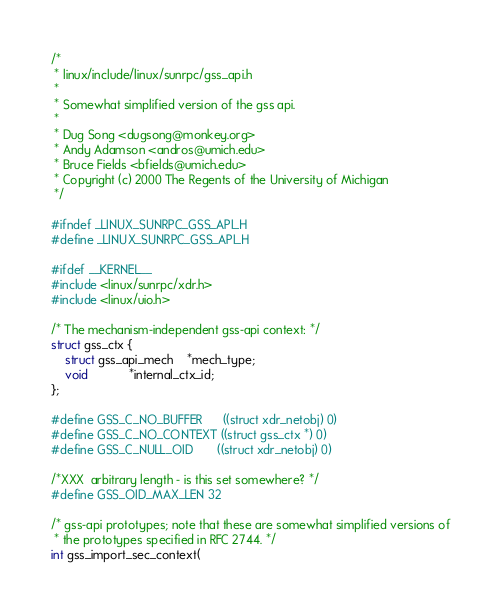Convert code to text. <code><loc_0><loc_0><loc_500><loc_500><_C_>/*
 * linux/include/linux/sunrpc/gss_api.h
 *
 * Somewhat simplified version of the gss api.
 *
 * Dug Song <dugsong@monkey.org>
 * Andy Adamson <andros@umich.edu>
 * Bruce Fields <bfields@umich.edu>
 * Copyright (c) 2000 The Regents of the University of Michigan
 */

#ifndef _LINUX_SUNRPC_GSS_API_H
#define _LINUX_SUNRPC_GSS_API_H

#ifdef __KERNEL__
#include <linux/sunrpc/xdr.h>
#include <linux/uio.h>

/* The mechanism-independent gss-api context: */
struct gss_ctx {
	struct gss_api_mech	*mech_type;
	void			*internal_ctx_id;
};

#define GSS_C_NO_BUFFER		((struct xdr_netobj) 0)
#define GSS_C_NO_CONTEXT	((struct gss_ctx *) 0)
#define GSS_C_NULL_OID		((struct xdr_netobj) 0)

/*XXX  arbitrary length - is this set somewhere? */
#define GSS_OID_MAX_LEN 32

/* gss-api prototypes; note that these are somewhat simplified versions of
 * the prototypes specified in RFC 2744. */
int gss_import_sec_context(</code> 